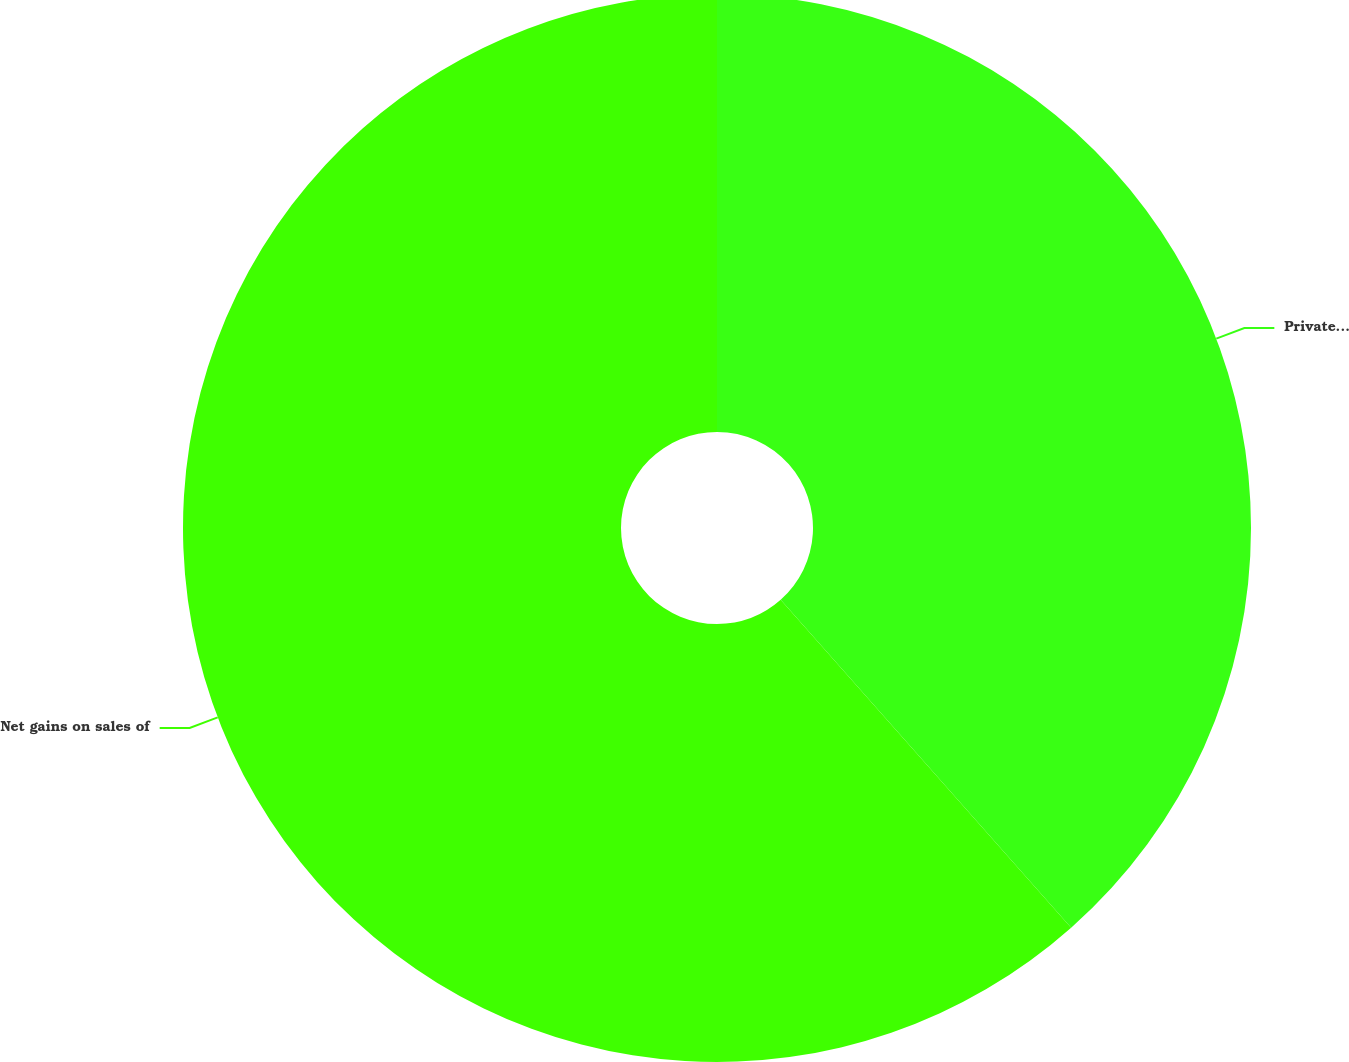<chart> <loc_0><loc_0><loc_500><loc_500><pie_chart><fcel>Private equity gains/(losses)<fcel>Net gains on sales of<nl><fcel>38.46%<fcel>61.54%<nl></chart> 